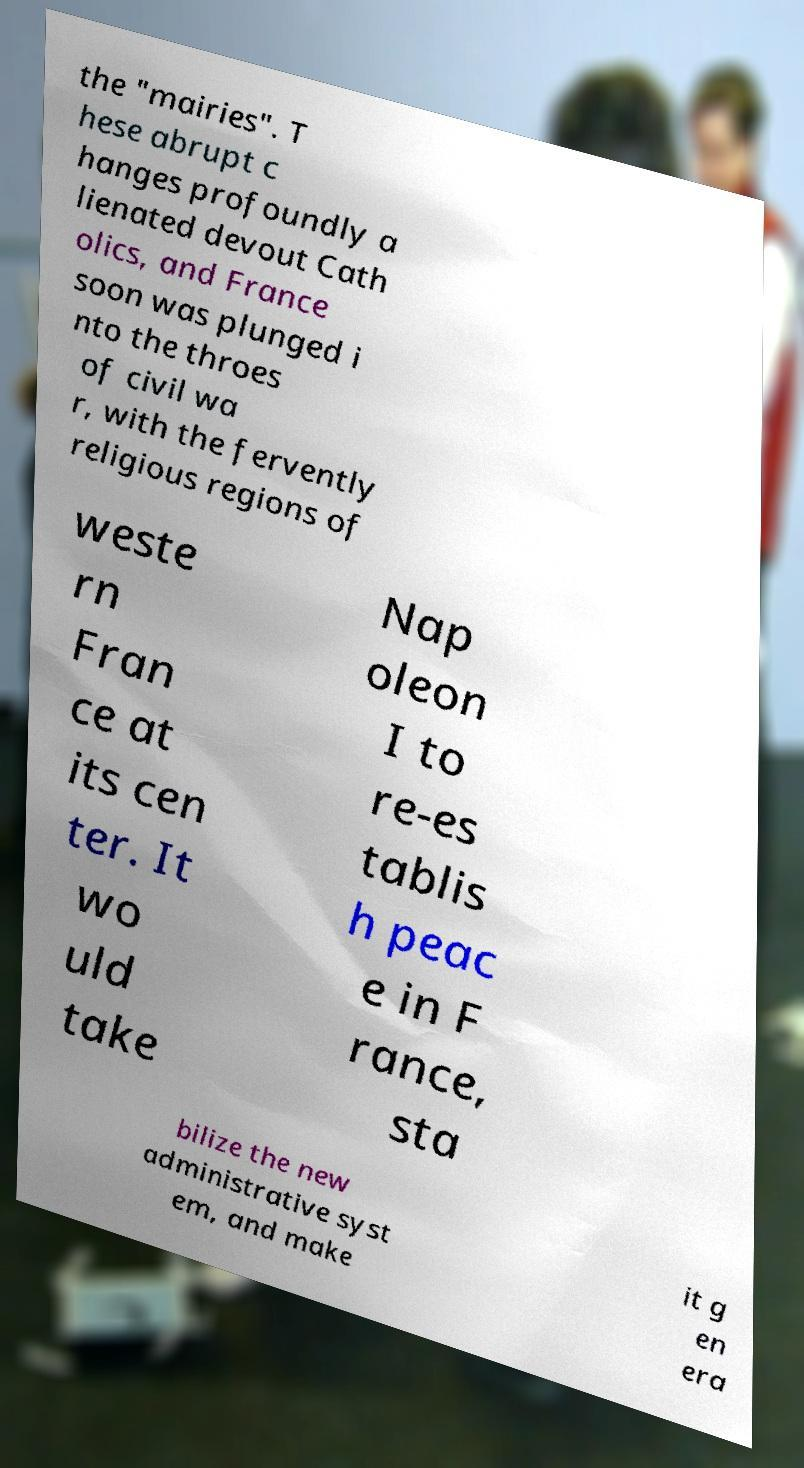Please identify and transcribe the text found in this image. the "mairies". T hese abrupt c hanges profoundly a lienated devout Cath olics, and France soon was plunged i nto the throes of civil wa r, with the fervently religious regions of weste rn Fran ce at its cen ter. It wo uld take Nap oleon I to re-es tablis h peac e in F rance, sta bilize the new administrative syst em, and make it g en era 